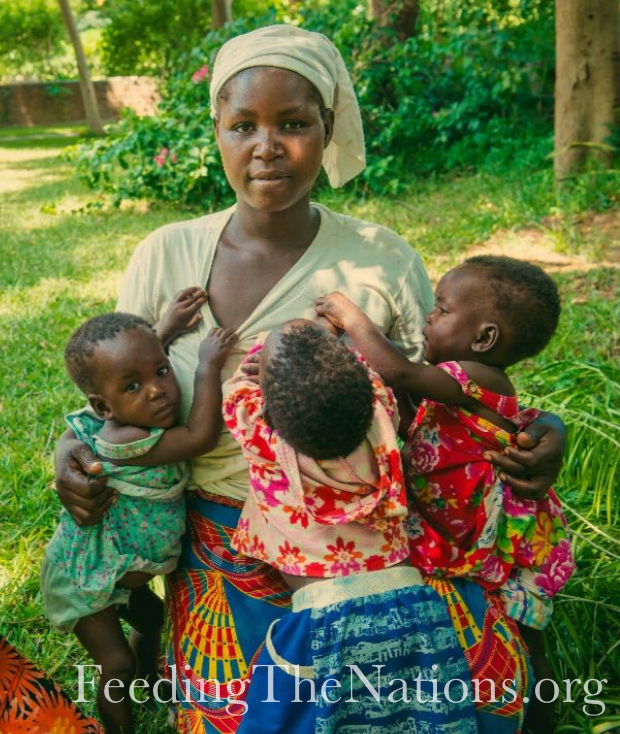Can you describe the environment surrounding the group and what it might indicate about their lifestyle or daily activities? The image shows the group in a lush, green outdoor setting that suggests they are in a rural or semi-rural area. The presence of healthy vegetation and trees indicates a close relationship with nature and possibly agriculture. This environment could also suggest their daily activities may include farming or gardening, which is common in rural communities worldwide. The natural setting also provides a serene backdrop, indicating a peaceful day-to-day environment away from urban hustle and bustle. 